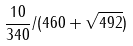<formula> <loc_0><loc_0><loc_500><loc_500>\frac { 1 0 } { 3 4 0 } / ( 4 6 0 + \sqrt { 4 9 2 } )</formula> 